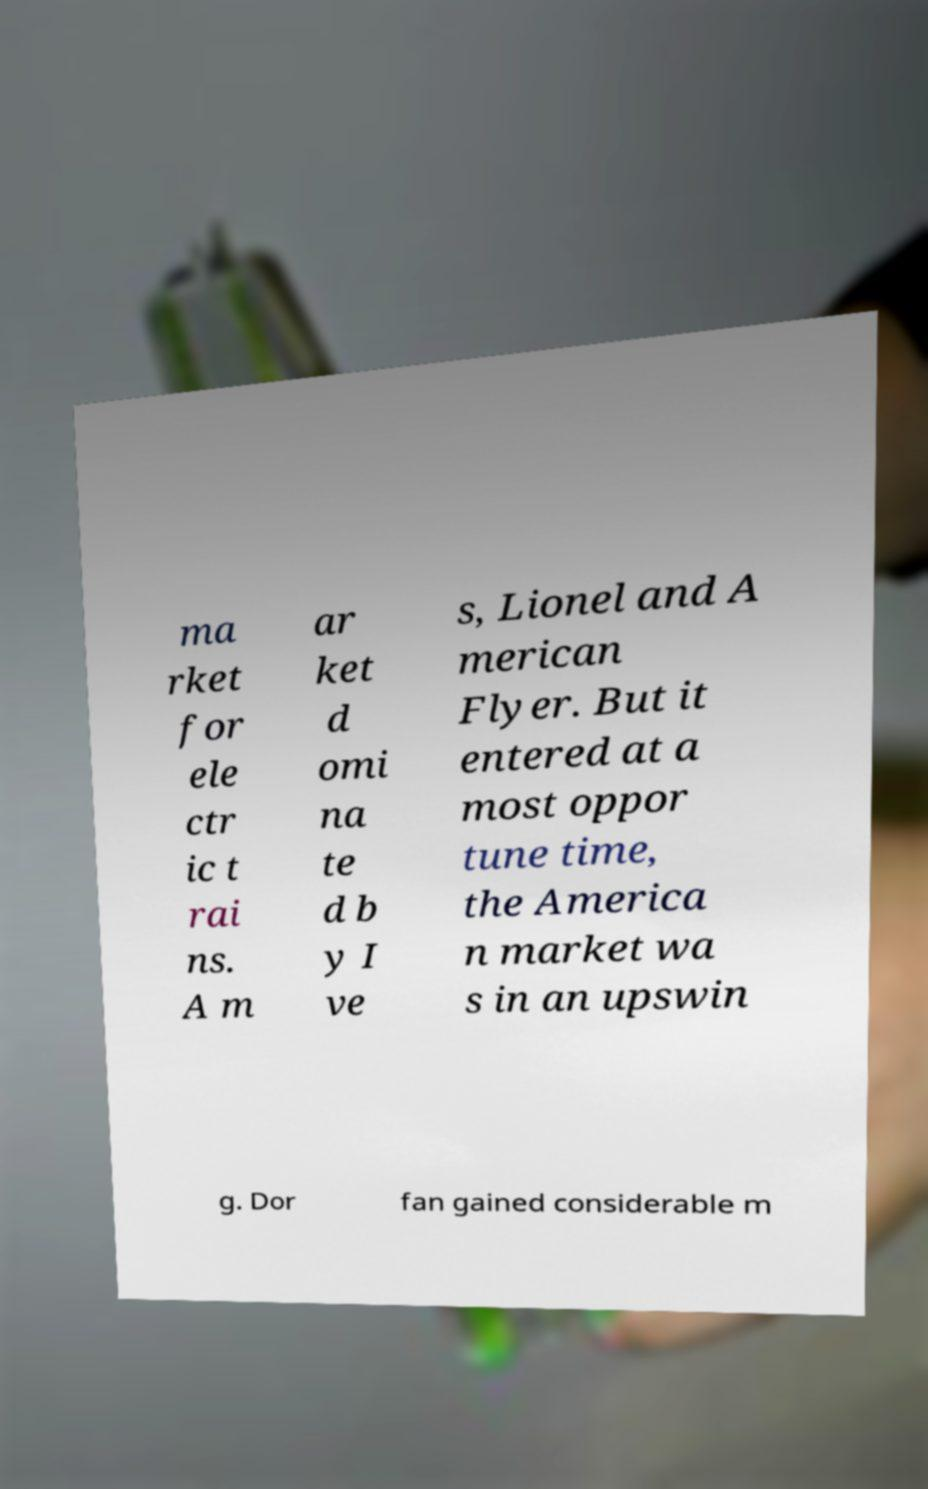For documentation purposes, I need the text within this image transcribed. Could you provide that? ma rket for ele ctr ic t rai ns. A m ar ket d omi na te d b y I ve s, Lionel and A merican Flyer. But it entered at a most oppor tune time, the America n market wa s in an upswin g. Dor fan gained considerable m 